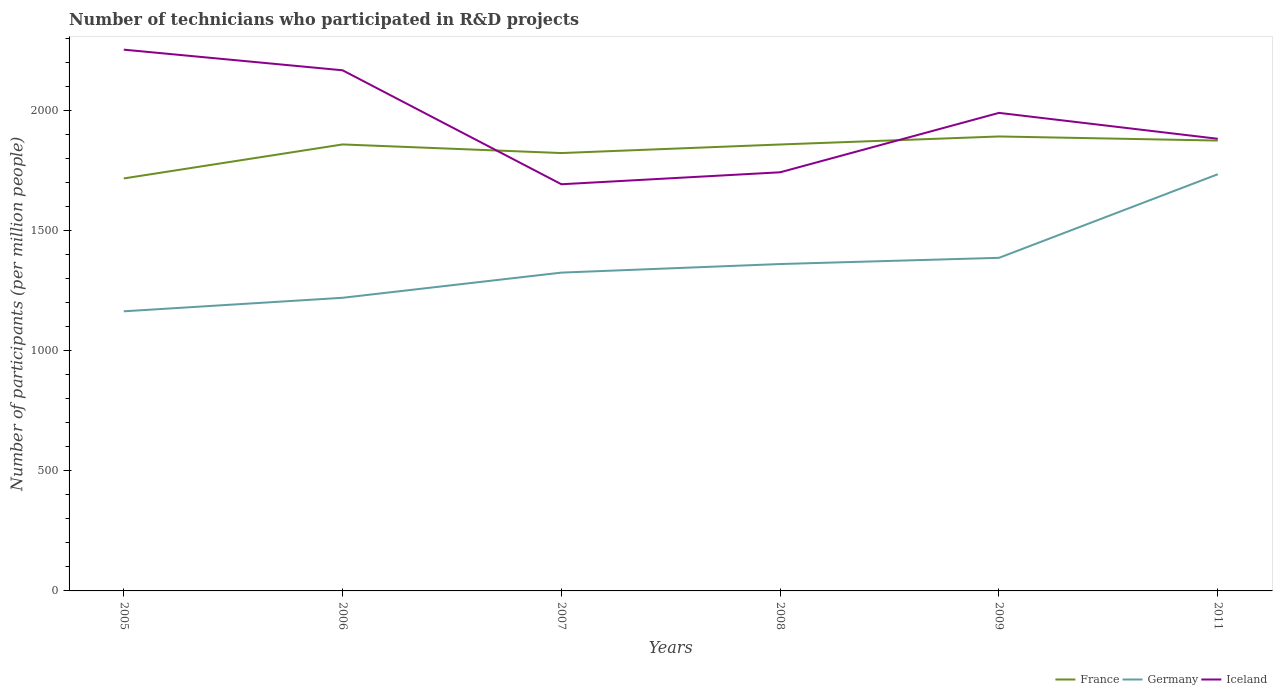How many different coloured lines are there?
Your answer should be very brief. 3. Does the line corresponding to France intersect with the line corresponding to Iceland?
Ensure brevity in your answer.  Yes. Is the number of lines equal to the number of legend labels?
Give a very brief answer. Yes. Across all years, what is the maximum number of technicians who participated in R&D projects in France?
Ensure brevity in your answer.  1717.32. What is the total number of technicians who participated in R&D projects in Iceland in the graph?
Offer a very short reply. 85.89. What is the difference between the highest and the second highest number of technicians who participated in R&D projects in Germany?
Keep it short and to the point. 570.64. What is the difference between the highest and the lowest number of technicians who participated in R&D projects in Germany?
Offer a very short reply. 2. Is the number of technicians who participated in R&D projects in Iceland strictly greater than the number of technicians who participated in R&D projects in France over the years?
Offer a very short reply. No. How many years are there in the graph?
Give a very brief answer. 6. What is the difference between two consecutive major ticks on the Y-axis?
Your answer should be very brief. 500. Does the graph contain any zero values?
Offer a very short reply. No. How many legend labels are there?
Make the answer very short. 3. What is the title of the graph?
Provide a succinct answer. Number of technicians who participated in R&D projects. Does "Namibia" appear as one of the legend labels in the graph?
Your response must be concise. No. What is the label or title of the X-axis?
Provide a short and direct response. Years. What is the label or title of the Y-axis?
Your response must be concise. Number of participants (per million people). What is the Number of participants (per million people) in France in 2005?
Offer a terse response. 1717.32. What is the Number of participants (per million people) of Germany in 2005?
Give a very brief answer. 1164.08. What is the Number of participants (per million people) of Iceland in 2005?
Your answer should be very brief. 2253.45. What is the Number of participants (per million people) in France in 2006?
Provide a short and direct response. 1858.87. What is the Number of participants (per million people) in Germany in 2006?
Provide a succinct answer. 1220.42. What is the Number of participants (per million people) of Iceland in 2006?
Your response must be concise. 2167.56. What is the Number of participants (per million people) of France in 2007?
Provide a succinct answer. 1823. What is the Number of participants (per million people) in Germany in 2007?
Make the answer very short. 1325.22. What is the Number of participants (per million people) in Iceland in 2007?
Ensure brevity in your answer.  1693.11. What is the Number of participants (per million people) of France in 2008?
Give a very brief answer. 1858.64. What is the Number of participants (per million people) in Germany in 2008?
Offer a very short reply. 1360.92. What is the Number of participants (per million people) of Iceland in 2008?
Ensure brevity in your answer.  1742.94. What is the Number of participants (per million people) of France in 2009?
Your answer should be very brief. 1892.04. What is the Number of participants (per million people) of Germany in 2009?
Give a very brief answer. 1386.74. What is the Number of participants (per million people) in Iceland in 2009?
Offer a terse response. 1990.23. What is the Number of participants (per million people) of France in 2011?
Your response must be concise. 1875.04. What is the Number of participants (per million people) of Germany in 2011?
Provide a short and direct response. 1734.73. What is the Number of participants (per million people) in Iceland in 2011?
Make the answer very short. 1882.38. Across all years, what is the maximum Number of participants (per million people) in France?
Your response must be concise. 1892.04. Across all years, what is the maximum Number of participants (per million people) in Germany?
Offer a very short reply. 1734.73. Across all years, what is the maximum Number of participants (per million people) in Iceland?
Keep it short and to the point. 2253.45. Across all years, what is the minimum Number of participants (per million people) of France?
Your answer should be very brief. 1717.32. Across all years, what is the minimum Number of participants (per million people) of Germany?
Provide a succinct answer. 1164.08. Across all years, what is the minimum Number of participants (per million people) of Iceland?
Offer a terse response. 1693.11. What is the total Number of participants (per million people) in France in the graph?
Give a very brief answer. 1.10e+04. What is the total Number of participants (per million people) of Germany in the graph?
Your answer should be very brief. 8192.11. What is the total Number of participants (per million people) in Iceland in the graph?
Give a very brief answer. 1.17e+04. What is the difference between the Number of participants (per million people) in France in 2005 and that in 2006?
Your response must be concise. -141.55. What is the difference between the Number of participants (per million people) of Germany in 2005 and that in 2006?
Provide a succinct answer. -56.33. What is the difference between the Number of participants (per million people) of Iceland in 2005 and that in 2006?
Give a very brief answer. 85.89. What is the difference between the Number of participants (per million people) in France in 2005 and that in 2007?
Give a very brief answer. -105.69. What is the difference between the Number of participants (per million people) in Germany in 2005 and that in 2007?
Provide a succinct answer. -161.14. What is the difference between the Number of participants (per million people) of Iceland in 2005 and that in 2007?
Your answer should be very brief. 560.34. What is the difference between the Number of participants (per million people) in France in 2005 and that in 2008?
Provide a succinct answer. -141.33. What is the difference between the Number of participants (per million people) in Germany in 2005 and that in 2008?
Your answer should be compact. -196.84. What is the difference between the Number of participants (per million people) of Iceland in 2005 and that in 2008?
Your answer should be compact. 510.51. What is the difference between the Number of participants (per million people) in France in 2005 and that in 2009?
Offer a very short reply. -174.72. What is the difference between the Number of participants (per million people) in Germany in 2005 and that in 2009?
Offer a very short reply. -222.66. What is the difference between the Number of participants (per million people) in Iceland in 2005 and that in 2009?
Make the answer very short. 263.22. What is the difference between the Number of participants (per million people) of France in 2005 and that in 2011?
Ensure brevity in your answer.  -157.72. What is the difference between the Number of participants (per million people) of Germany in 2005 and that in 2011?
Ensure brevity in your answer.  -570.64. What is the difference between the Number of participants (per million people) of Iceland in 2005 and that in 2011?
Your answer should be compact. 371.07. What is the difference between the Number of participants (per million people) of France in 2006 and that in 2007?
Ensure brevity in your answer.  35.86. What is the difference between the Number of participants (per million people) of Germany in 2006 and that in 2007?
Ensure brevity in your answer.  -104.8. What is the difference between the Number of participants (per million people) in Iceland in 2006 and that in 2007?
Give a very brief answer. 474.45. What is the difference between the Number of participants (per million people) of France in 2006 and that in 2008?
Ensure brevity in your answer.  0.22. What is the difference between the Number of participants (per million people) of Germany in 2006 and that in 2008?
Keep it short and to the point. -140.5. What is the difference between the Number of participants (per million people) of Iceland in 2006 and that in 2008?
Your answer should be compact. 424.61. What is the difference between the Number of participants (per million people) in France in 2006 and that in 2009?
Make the answer very short. -33.17. What is the difference between the Number of participants (per million people) in Germany in 2006 and that in 2009?
Your response must be concise. -166.33. What is the difference between the Number of participants (per million people) of Iceland in 2006 and that in 2009?
Your response must be concise. 177.33. What is the difference between the Number of participants (per million people) in France in 2006 and that in 2011?
Make the answer very short. -16.17. What is the difference between the Number of participants (per million people) in Germany in 2006 and that in 2011?
Your response must be concise. -514.31. What is the difference between the Number of participants (per million people) in Iceland in 2006 and that in 2011?
Your response must be concise. 285.18. What is the difference between the Number of participants (per million people) in France in 2007 and that in 2008?
Make the answer very short. -35.64. What is the difference between the Number of participants (per million people) of Germany in 2007 and that in 2008?
Your answer should be compact. -35.7. What is the difference between the Number of participants (per million people) in Iceland in 2007 and that in 2008?
Offer a very short reply. -49.84. What is the difference between the Number of participants (per million people) of France in 2007 and that in 2009?
Your answer should be very brief. -69.04. What is the difference between the Number of participants (per million people) in Germany in 2007 and that in 2009?
Your response must be concise. -61.52. What is the difference between the Number of participants (per million people) in Iceland in 2007 and that in 2009?
Offer a terse response. -297.12. What is the difference between the Number of participants (per million people) of France in 2007 and that in 2011?
Offer a very short reply. -52.04. What is the difference between the Number of participants (per million people) in Germany in 2007 and that in 2011?
Make the answer very short. -409.51. What is the difference between the Number of participants (per million people) of Iceland in 2007 and that in 2011?
Keep it short and to the point. -189.27. What is the difference between the Number of participants (per million people) of France in 2008 and that in 2009?
Make the answer very short. -33.4. What is the difference between the Number of participants (per million people) in Germany in 2008 and that in 2009?
Provide a short and direct response. -25.82. What is the difference between the Number of participants (per million people) in Iceland in 2008 and that in 2009?
Offer a terse response. -247.28. What is the difference between the Number of participants (per million people) of France in 2008 and that in 2011?
Offer a terse response. -16.4. What is the difference between the Number of participants (per million people) of Germany in 2008 and that in 2011?
Offer a terse response. -373.81. What is the difference between the Number of participants (per million people) in Iceland in 2008 and that in 2011?
Ensure brevity in your answer.  -139.44. What is the difference between the Number of participants (per million people) of France in 2009 and that in 2011?
Provide a succinct answer. 17. What is the difference between the Number of participants (per million people) of Germany in 2009 and that in 2011?
Your answer should be compact. -347.98. What is the difference between the Number of participants (per million people) in Iceland in 2009 and that in 2011?
Ensure brevity in your answer.  107.85. What is the difference between the Number of participants (per million people) of France in 2005 and the Number of participants (per million people) of Germany in 2006?
Your response must be concise. 496.9. What is the difference between the Number of participants (per million people) of France in 2005 and the Number of participants (per million people) of Iceland in 2006?
Your answer should be very brief. -450.24. What is the difference between the Number of participants (per million people) of Germany in 2005 and the Number of participants (per million people) of Iceland in 2006?
Your answer should be compact. -1003.48. What is the difference between the Number of participants (per million people) of France in 2005 and the Number of participants (per million people) of Germany in 2007?
Your response must be concise. 392.1. What is the difference between the Number of participants (per million people) of France in 2005 and the Number of participants (per million people) of Iceland in 2007?
Your answer should be very brief. 24.21. What is the difference between the Number of participants (per million people) in Germany in 2005 and the Number of participants (per million people) in Iceland in 2007?
Your answer should be very brief. -529.02. What is the difference between the Number of participants (per million people) of France in 2005 and the Number of participants (per million people) of Germany in 2008?
Your answer should be very brief. 356.4. What is the difference between the Number of participants (per million people) in France in 2005 and the Number of participants (per million people) in Iceland in 2008?
Keep it short and to the point. -25.63. What is the difference between the Number of participants (per million people) in Germany in 2005 and the Number of participants (per million people) in Iceland in 2008?
Your answer should be very brief. -578.86. What is the difference between the Number of participants (per million people) of France in 2005 and the Number of participants (per million people) of Germany in 2009?
Provide a succinct answer. 330.57. What is the difference between the Number of participants (per million people) of France in 2005 and the Number of participants (per million people) of Iceland in 2009?
Keep it short and to the point. -272.91. What is the difference between the Number of participants (per million people) in Germany in 2005 and the Number of participants (per million people) in Iceland in 2009?
Offer a very short reply. -826.14. What is the difference between the Number of participants (per million people) in France in 2005 and the Number of participants (per million people) in Germany in 2011?
Make the answer very short. -17.41. What is the difference between the Number of participants (per million people) in France in 2005 and the Number of participants (per million people) in Iceland in 2011?
Provide a succinct answer. -165.06. What is the difference between the Number of participants (per million people) in Germany in 2005 and the Number of participants (per million people) in Iceland in 2011?
Provide a short and direct response. -718.3. What is the difference between the Number of participants (per million people) in France in 2006 and the Number of participants (per million people) in Germany in 2007?
Make the answer very short. 533.65. What is the difference between the Number of participants (per million people) in France in 2006 and the Number of participants (per million people) in Iceland in 2007?
Provide a succinct answer. 165.76. What is the difference between the Number of participants (per million people) of Germany in 2006 and the Number of participants (per million people) of Iceland in 2007?
Give a very brief answer. -472.69. What is the difference between the Number of participants (per million people) of France in 2006 and the Number of participants (per million people) of Germany in 2008?
Your answer should be very brief. 497.95. What is the difference between the Number of participants (per million people) in France in 2006 and the Number of participants (per million people) in Iceland in 2008?
Provide a succinct answer. 115.92. What is the difference between the Number of participants (per million people) of Germany in 2006 and the Number of participants (per million people) of Iceland in 2008?
Make the answer very short. -522.53. What is the difference between the Number of participants (per million people) in France in 2006 and the Number of participants (per million people) in Germany in 2009?
Your answer should be compact. 472.12. What is the difference between the Number of participants (per million people) in France in 2006 and the Number of participants (per million people) in Iceland in 2009?
Provide a short and direct response. -131.36. What is the difference between the Number of participants (per million people) in Germany in 2006 and the Number of participants (per million people) in Iceland in 2009?
Offer a very short reply. -769.81. What is the difference between the Number of participants (per million people) in France in 2006 and the Number of participants (per million people) in Germany in 2011?
Provide a short and direct response. 124.14. What is the difference between the Number of participants (per million people) of France in 2006 and the Number of participants (per million people) of Iceland in 2011?
Provide a short and direct response. -23.51. What is the difference between the Number of participants (per million people) in Germany in 2006 and the Number of participants (per million people) in Iceland in 2011?
Your answer should be compact. -661.96. What is the difference between the Number of participants (per million people) of France in 2007 and the Number of participants (per million people) of Germany in 2008?
Offer a very short reply. 462.08. What is the difference between the Number of participants (per million people) in France in 2007 and the Number of participants (per million people) in Iceland in 2008?
Your response must be concise. 80.06. What is the difference between the Number of participants (per million people) in Germany in 2007 and the Number of participants (per million people) in Iceland in 2008?
Provide a succinct answer. -417.72. What is the difference between the Number of participants (per million people) of France in 2007 and the Number of participants (per million people) of Germany in 2009?
Offer a very short reply. 436.26. What is the difference between the Number of participants (per million people) in France in 2007 and the Number of participants (per million people) in Iceland in 2009?
Make the answer very short. -167.22. What is the difference between the Number of participants (per million people) of Germany in 2007 and the Number of participants (per million people) of Iceland in 2009?
Your answer should be compact. -665.01. What is the difference between the Number of participants (per million people) in France in 2007 and the Number of participants (per million people) in Germany in 2011?
Your answer should be compact. 88.28. What is the difference between the Number of participants (per million people) of France in 2007 and the Number of participants (per million people) of Iceland in 2011?
Make the answer very short. -59.38. What is the difference between the Number of participants (per million people) of Germany in 2007 and the Number of participants (per million people) of Iceland in 2011?
Keep it short and to the point. -557.16. What is the difference between the Number of participants (per million people) of France in 2008 and the Number of participants (per million people) of Germany in 2009?
Give a very brief answer. 471.9. What is the difference between the Number of participants (per million people) in France in 2008 and the Number of participants (per million people) in Iceland in 2009?
Make the answer very short. -131.59. What is the difference between the Number of participants (per million people) in Germany in 2008 and the Number of participants (per million people) in Iceland in 2009?
Your answer should be compact. -629.31. What is the difference between the Number of participants (per million people) in France in 2008 and the Number of participants (per million people) in Germany in 2011?
Make the answer very short. 123.92. What is the difference between the Number of participants (per million people) in France in 2008 and the Number of participants (per million people) in Iceland in 2011?
Ensure brevity in your answer.  -23.74. What is the difference between the Number of participants (per million people) in Germany in 2008 and the Number of participants (per million people) in Iceland in 2011?
Offer a terse response. -521.46. What is the difference between the Number of participants (per million people) in France in 2009 and the Number of participants (per million people) in Germany in 2011?
Your answer should be compact. 157.31. What is the difference between the Number of participants (per million people) of France in 2009 and the Number of participants (per million people) of Iceland in 2011?
Keep it short and to the point. 9.66. What is the difference between the Number of participants (per million people) in Germany in 2009 and the Number of participants (per million people) in Iceland in 2011?
Ensure brevity in your answer.  -495.63. What is the average Number of participants (per million people) of France per year?
Ensure brevity in your answer.  1837.48. What is the average Number of participants (per million people) in Germany per year?
Offer a terse response. 1365.35. What is the average Number of participants (per million people) in Iceland per year?
Your answer should be very brief. 1954.94. In the year 2005, what is the difference between the Number of participants (per million people) in France and Number of participants (per million people) in Germany?
Offer a very short reply. 553.23. In the year 2005, what is the difference between the Number of participants (per million people) of France and Number of participants (per million people) of Iceland?
Ensure brevity in your answer.  -536.13. In the year 2005, what is the difference between the Number of participants (per million people) of Germany and Number of participants (per million people) of Iceland?
Your answer should be compact. -1089.37. In the year 2006, what is the difference between the Number of participants (per million people) of France and Number of participants (per million people) of Germany?
Offer a terse response. 638.45. In the year 2006, what is the difference between the Number of participants (per million people) of France and Number of participants (per million people) of Iceland?
Make the answer very short. -308.69. In the year 2006, what is the difference between the Number of participants (per million people) in Germany and Number of participants (per million people) in Iceland?
Offer a very short reply. -947.14. In the year 2007, what is the difference between the Number of participants (per million people) in France and Number of participants (per million people) in Germany?
Keep it short and to the point. 497.78. In the year 2007, what is the difference between the Number of participants (per million people) in France and Number of participants (per million people) in Iceland?
Keep it short and to the point. 129.9. In the year 2007, what is the difference between the Number of participants (per million people) in Germany and Number of participants (per million people) in Iceland?
Keep it short and to the point. -367.89. In the year 2008, what is the difference between the Number of participants (per million people) in France and Number of participants (per million people) in Germany?
Give a very brief answer. 497.72. In the year 2008, what is the difference between the Number of participants (per million people) in France and Number of participants (per million people) in Iceland?
Your answer should be compact. 115.7. In the year 2008, what is the difference between the Number of participants (per million people) in Germany and Number of participants (per million people) in Iceland?
Give a very brief answer. -382.02. In the year 2009, what is the difference between the Number of participants (per million people) in France and Number of participants (per million people) in Germany?
Ensure brevity in your answer.  505.3. In the year 2009, what is the difference between the Number of participants (per million people) in France and Number of participants (per million people) in Iceland?
Give a very brief answer. -98.19. In the year 2009, what is the difference between the Number of participants (per million people) of Germany and Number of participants (per million people) of Iceland?
Provide a short and direct response. -603.48. In the year 2011, what is the difference between the Number of participants (per million people) of France and Number of participants (per million people) of Germany?
Your answer should be compact. 140.31. In the year 2011, what is the difference between the Number of participants (per million people) in France and Number of participants (per million people) in Iceland?
Provide a succinct answer. -7.34. In the year 2011, what is the difference between the Number of participants (per million people) in Germany and Number of participants (per million people) in Iceland?
Make the answer very short. -147.65. What is the ratio of the Number of participants (per million people) of France in 2005 to that in 2006?
Keep it short and to the point. 0.92. What is the ratio of the Number of participants (per million people) in Germany in 2005 to that in 2006?
Offer a very short reply. 0.95. What is the ratio of the Number of participants (per million people) of Iceland in 2005 to that in 2006?
Provide a short and direct response. 1.04. What is the ratio of the Number of participants (per million people) of France in 2005 to that in 2007?
Your answer should be compact. 0.94. What is the ratio of the Number of participants (per million people) of Germany in 2005 to that in 2007?
Your answer should be compact. 0.88. What is the ratio of the Number of participants (per million people) in Iceland in 2005 to that in 2007?
Your answer should be very brief. 1.33. What is the ratio of the Number of participants (per million people) of France in 2005 to that in 2008?
Provide a short and direct response. 0.92. What is the ratio of the Number of participants (per million people) of Germany in 2005 to that in 2008?
Provide a short and direct response. 0.86. What is the ratio of the Number of participants (per million people) of Iceland in 2005 to that in 2008?
Your answer should be compact. 1.29. What is the ratio of the Number of participants (per million people) in France in 2005 to that in 2009?
Ensure brevity in your answer.  0.91. What is the ratio of the Number of participants (per million people) in Germany in 2005 to that in 2009?
Your answer should be very brief. 0.84. What is the ratio of the Number of participants (per million people) in Iceland in 2005 to that in 2009?
Provide a succinct answer. 1.13. What is the ratio of the Number of participants (per million people) of France in 2005 to that in 2011?
Keep it short and to the point. 0.92. What is the ratio of the Number of participants (per million people) of Germany in 2005 to that in 2011?
Ensure brevity in your answer.  0.67. What is the ratio of the Number of participants (per million people) in Iceland in 2005 to that in 2011?
Make the answer very short. 1.2. What is the ratio of the Number of participants (per million people) in France in 2006 to that in 2007?
Ensure brevity in your answer.  1.02. What is the ratio of the Number of participants (per million people) in Germany in 2006 to that in 2007?
Give a very brief answer. 0.92. What is the ratio of the Number of participants (per million people) of Iceland in 2006 to that in 2007?
Offer a terse response. 1.28. What is the ratio of the Number of participants (per million people) of Germany in 2006 to that in 2008?
Offer a very short reply. 0.9. What is the ratio of the Number of participants (per million people) of Iceland in 2006 to that in 2008?
Make the answer very short. 1.24. What is the ratio of the Number of participants (per million people) of France in 2006 to that in 2009?
Make the answer very short. 0.98. What is the ratio of the Number of participants (per million people) in Germany in 2006 to that in 2009?
Give a very brief answer. 0.88. What is the ratio of the Number of participants (per million people) in Iceland in 2006 to that in 2009?
Your response must be concise. 1.09. What is the ratio of the Number of participants (per million people) of France in 2006 to that in 2011?
Make the answer very short. 0.99. What is the ratio of the Number of participants (per million people) of Germany in 2006 to that in 2011?
Your response must be concise. 0.7. What is the ratio of the Number of participants (per million people) in Iceland in 2006 to that in 2011?
Give a very brief answer. 1.15. What is the ratio of the Number of participants (per million people) of France in 2007 to that in 2008?
Offer a terse response. 0.98. What is the ratio of the Number of participants (per million people) of Germany in 2007 to that in 2008?
Your response must be concise. 0.97. What is the ratio of the Number of participants (per million people) of Iceland in 2007 to that in 2008?
Your answer should be very brief. 0.97. What is the ratio of the Number of participants (per million people) of France in 2007 to that in 2009?
Ensure brevity in your answer.  0.96. What is the ratio of the Number of participants (per million people) in Germany in 2007 to that in 2009?
Your answer should be very brief. 0.96. What is the ratio of the Number of participants (per million people) in Iceland in 2007 to that in 2009?
Your response must be concise. 0.85. What is the ratio of the Number of participants (per million people) of France in 2007 to that in 2011?
Offer a terse response. 0.97. What is the ratio of the Number of participants (per million people) of Germany in 2007 to that in 2011?
Provide a succinct answer. 0.76. What is the ratio of the Number of participants (per million people) in Iceland in 2007 to that in 2011?
Provide a short and direct response. 0.9. What is the ratio of the Number of participants (per million people) of France in 2008 to that in 2009?
Provide a succinct answer. 0.98. What is the ratio of the Number of participants (per million people) in Germany in 2008 to that in 2009?
Make the answer very short. 0.98. What is the ratio of the Number of participants (per million people) of Iceland in 2008 to that in 2009?
Keep it short and to the point. 0.88. What is the ratio of the Number of participants (per million people) in Germany in 2008 to that in 2011?
Your answer should be very brief. 0.78. What is the ratio of the Number of participants (per million people) of Iceland in 2008 to that in 2011?
Make the answer very short. 0.93. What is the ratio of the Number of participants (per million people) in France in 2009 to that in 2011?
Provide a succinct answer. 1.01. What is the ratio of the Number of participants (per million people) in Germany in 2009 to that in 2011?
Offer a terse response. 0.8. What is the ratio of the Number of participants (per million people) in Iceland in 2009 to that in 2011?
Give a very brief answer. 1.06. What is the difference between the highest and the second highest Number of participants (per million people) of France?
Keep it short and to the point. 17. What is the difference between the highest and the second highest Number of participants (per million people) in Germany?
Give a very brief answer. 347.98. What is the difference between the highest and the second highest Number of participants (per million people) in Iceland?
Your answer should be compact. 85.89. What is the difference between the highest and the lowest Number of participants (per million people) in France?
Your answer should be very brief. 174.72. What is the difference between the highest and the lowest Number of participants (per million people) of Germany?
Keep it short and to the point. 570.64. What is the difference between the highest and the lowest Number of participants (per million people) of Iceland?
Give a very brief answer. 560.34. 